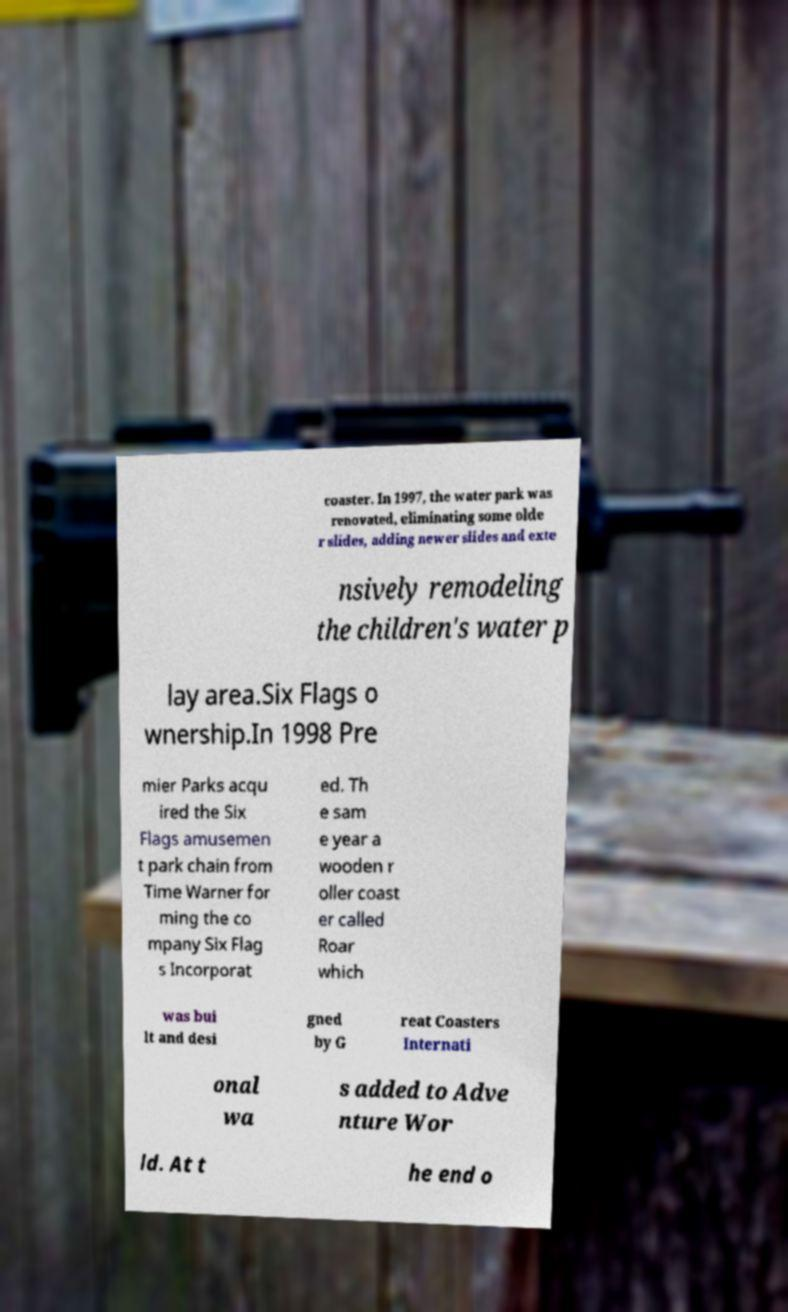Please identify and transcribe the text found in this image. coaster. In 1997, the water park was renovated, eliminating some olde r slides, adding newer slides and exte nsively remodeling the children's water p lay area.Six Flags o wnership.In 1998 Pre mier Parks acqu ired the Six Flags amusemen t park chain from Time Warner for ming the co mpany Six Flag s Incorporat ed. Th e sam e year a wooden r oller coast er called Roar which was bui lt and desi gned by G reat Coasters Internati onal wa s added to Adve nture Wor ld. At t he end o 